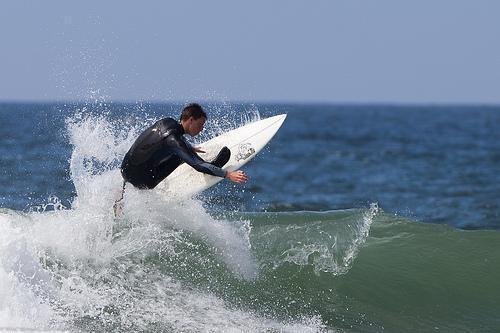How many people are in the photo?
Give a very brief answer. 1. 